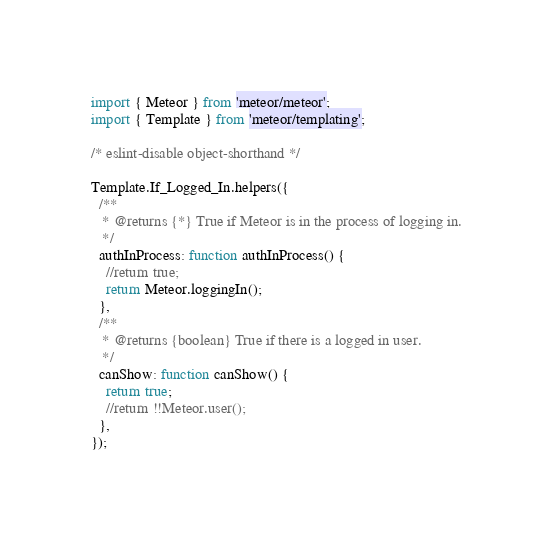Convert code to text. <code><loc_0><loc_0><loc_500><loc_500><_JavaScript_>import { Meteor } from 'meteor/meteor';
import { Template } from 'meteor/templating';

/* eslint-disable object-shorthand */

Template.If_Logged_In.helpers({
  /**
   * @returns {*} True if Meteor is in the process of logging in.
   */
  authInProcess: function authInProcess() {
    //return true;
    return Meteor.loggingIn();
  },
  /**
   * @returns {boolean} True if there is a logged in user.
   */
  canShow: function canShow() {
    return true;
    //return !!Meteor.user();
  },
});
</code> 